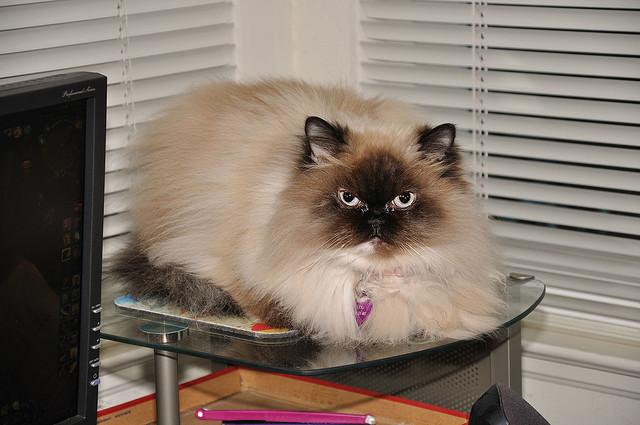How many windows?
Concise answer only. 2. What type of cat is this?
Be succinct. Persian. Is the cat about to pounce?
Keep it brief. No. 